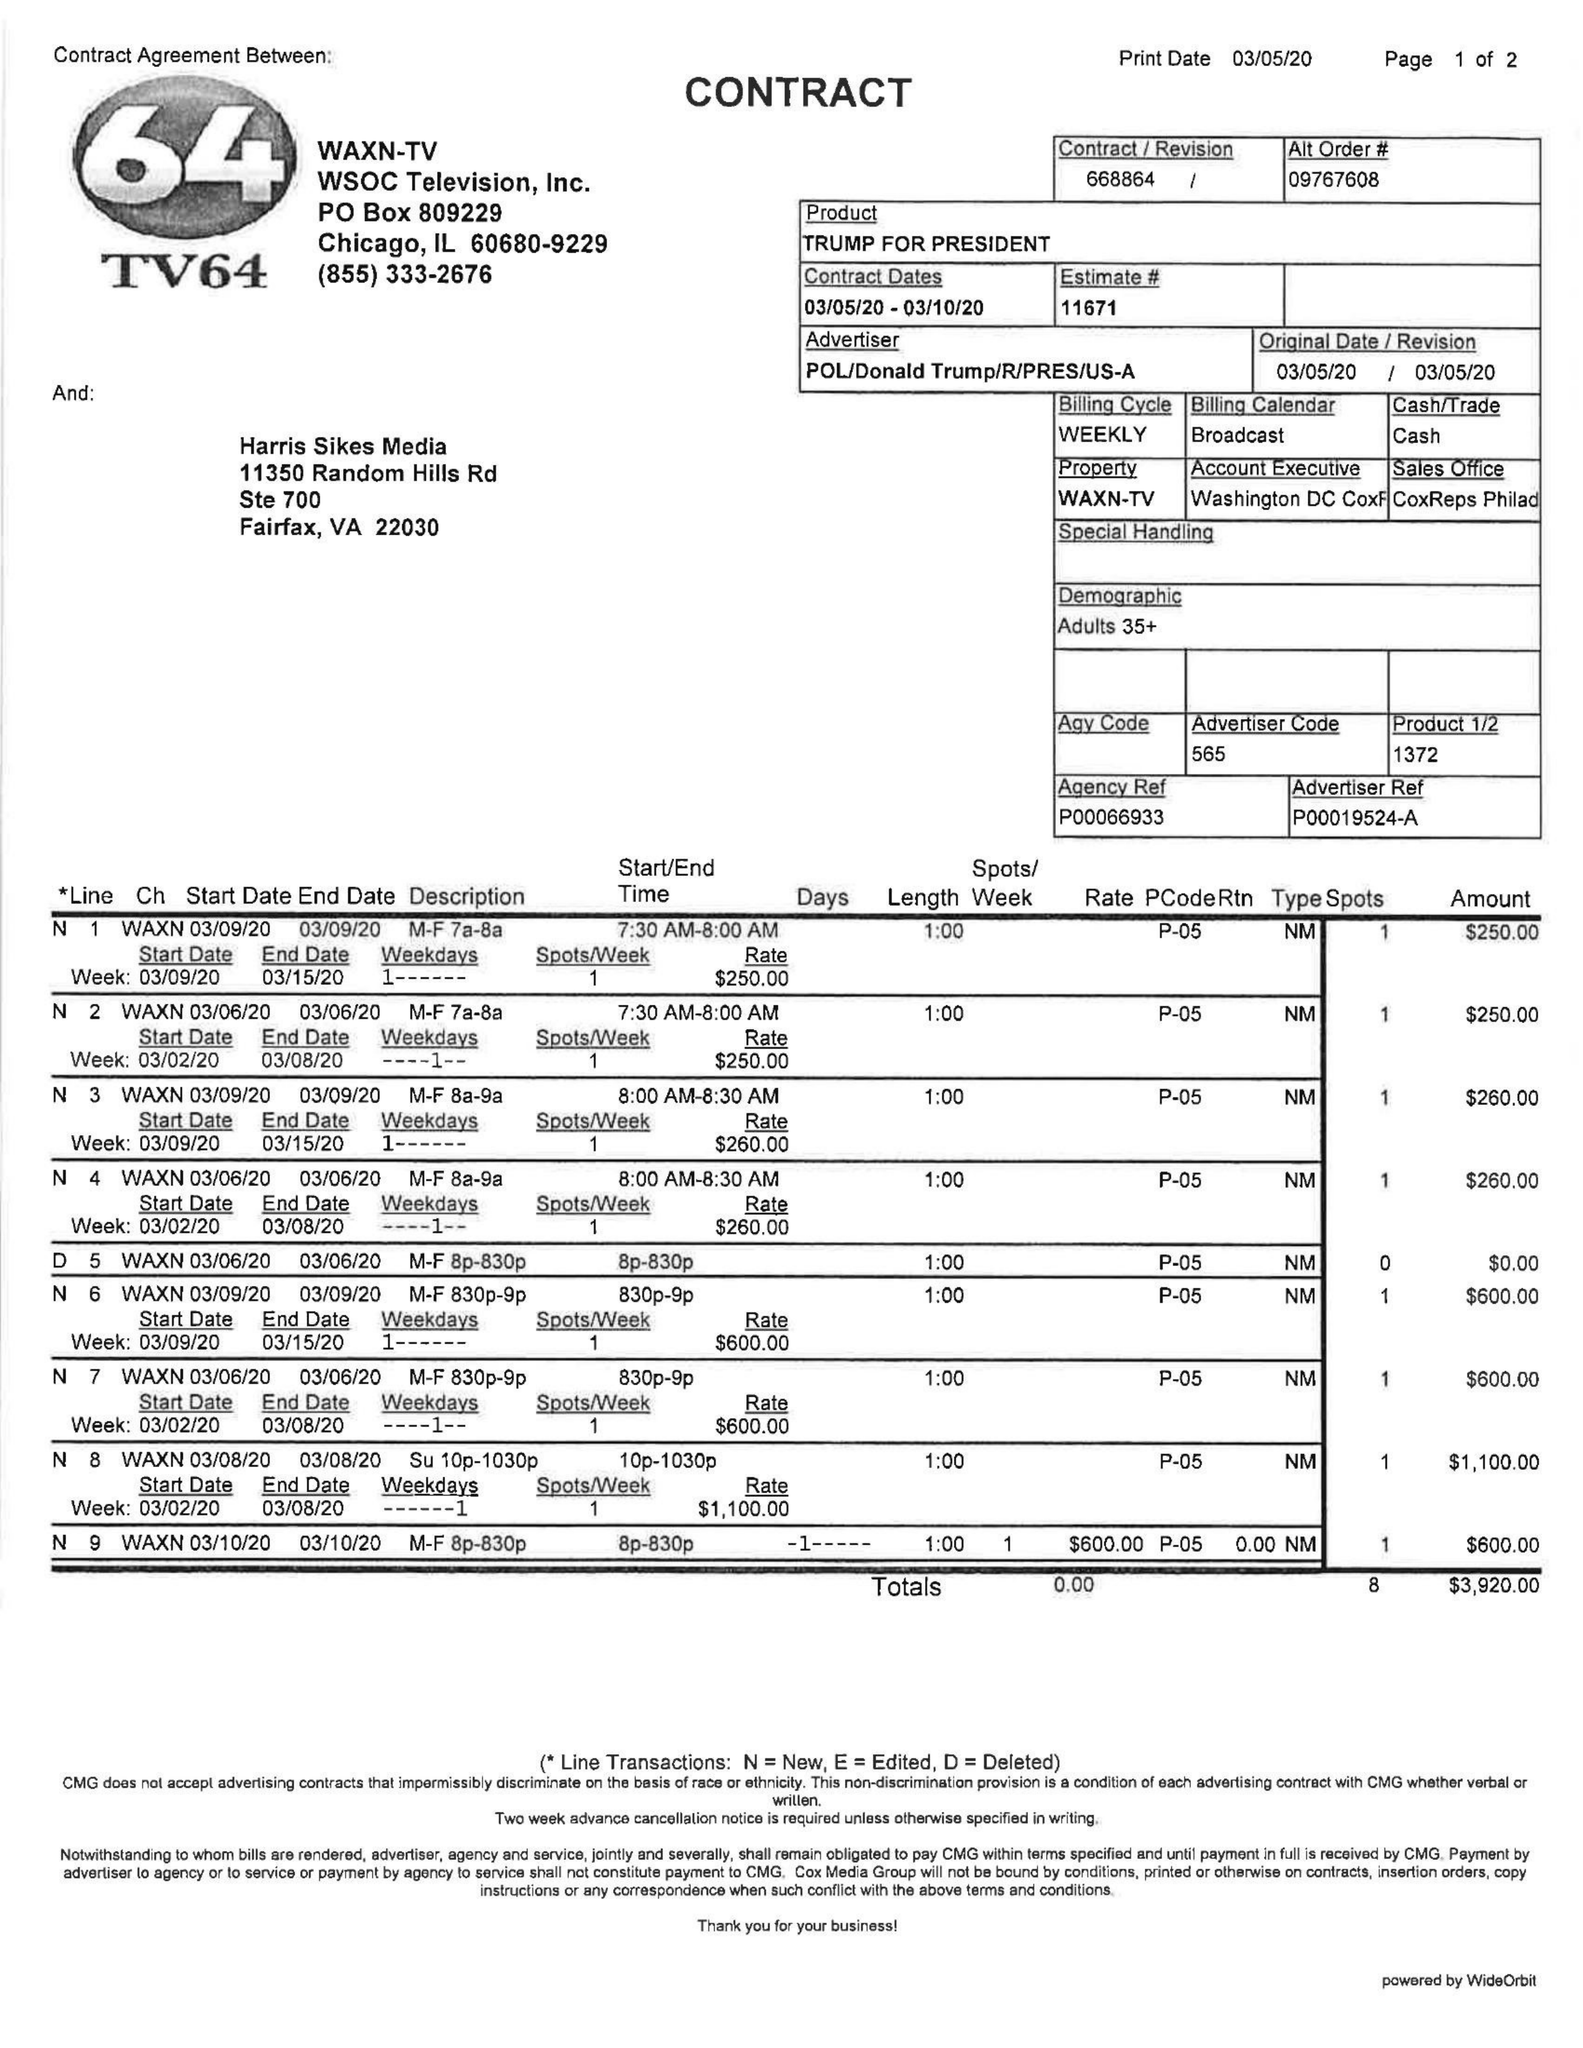What is the value for the advertiser?
Answer the question using a single word or phrase. POL/DONALDTRUMP/R/PRES/US-A 